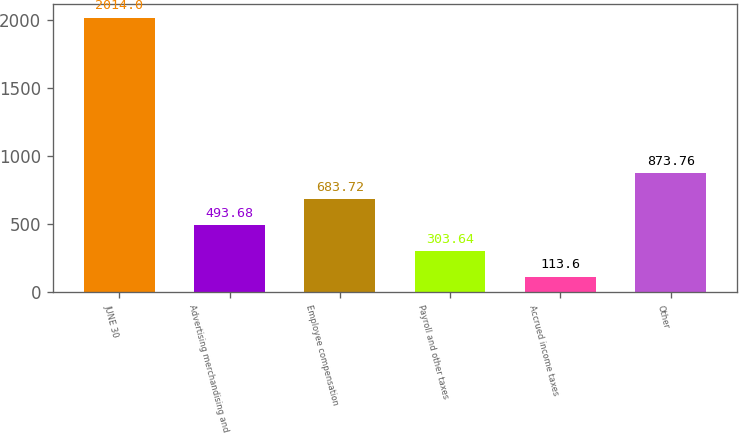Convert chart. <chart><loc_0><loc_0><loc_500><loc_500><bar_chart><fcel>JUNE 30<fcel>Advertising merchandising and<fcel>Employee compensation<fcel>Payroll and other taxes<fcel>Accrued income taxes<fcel>Other<nl><fcel>2014<fcel>493.68<fcel>683.72<fcel>303.64<fcel>113.6<fcel>873.76<nl></chart> 